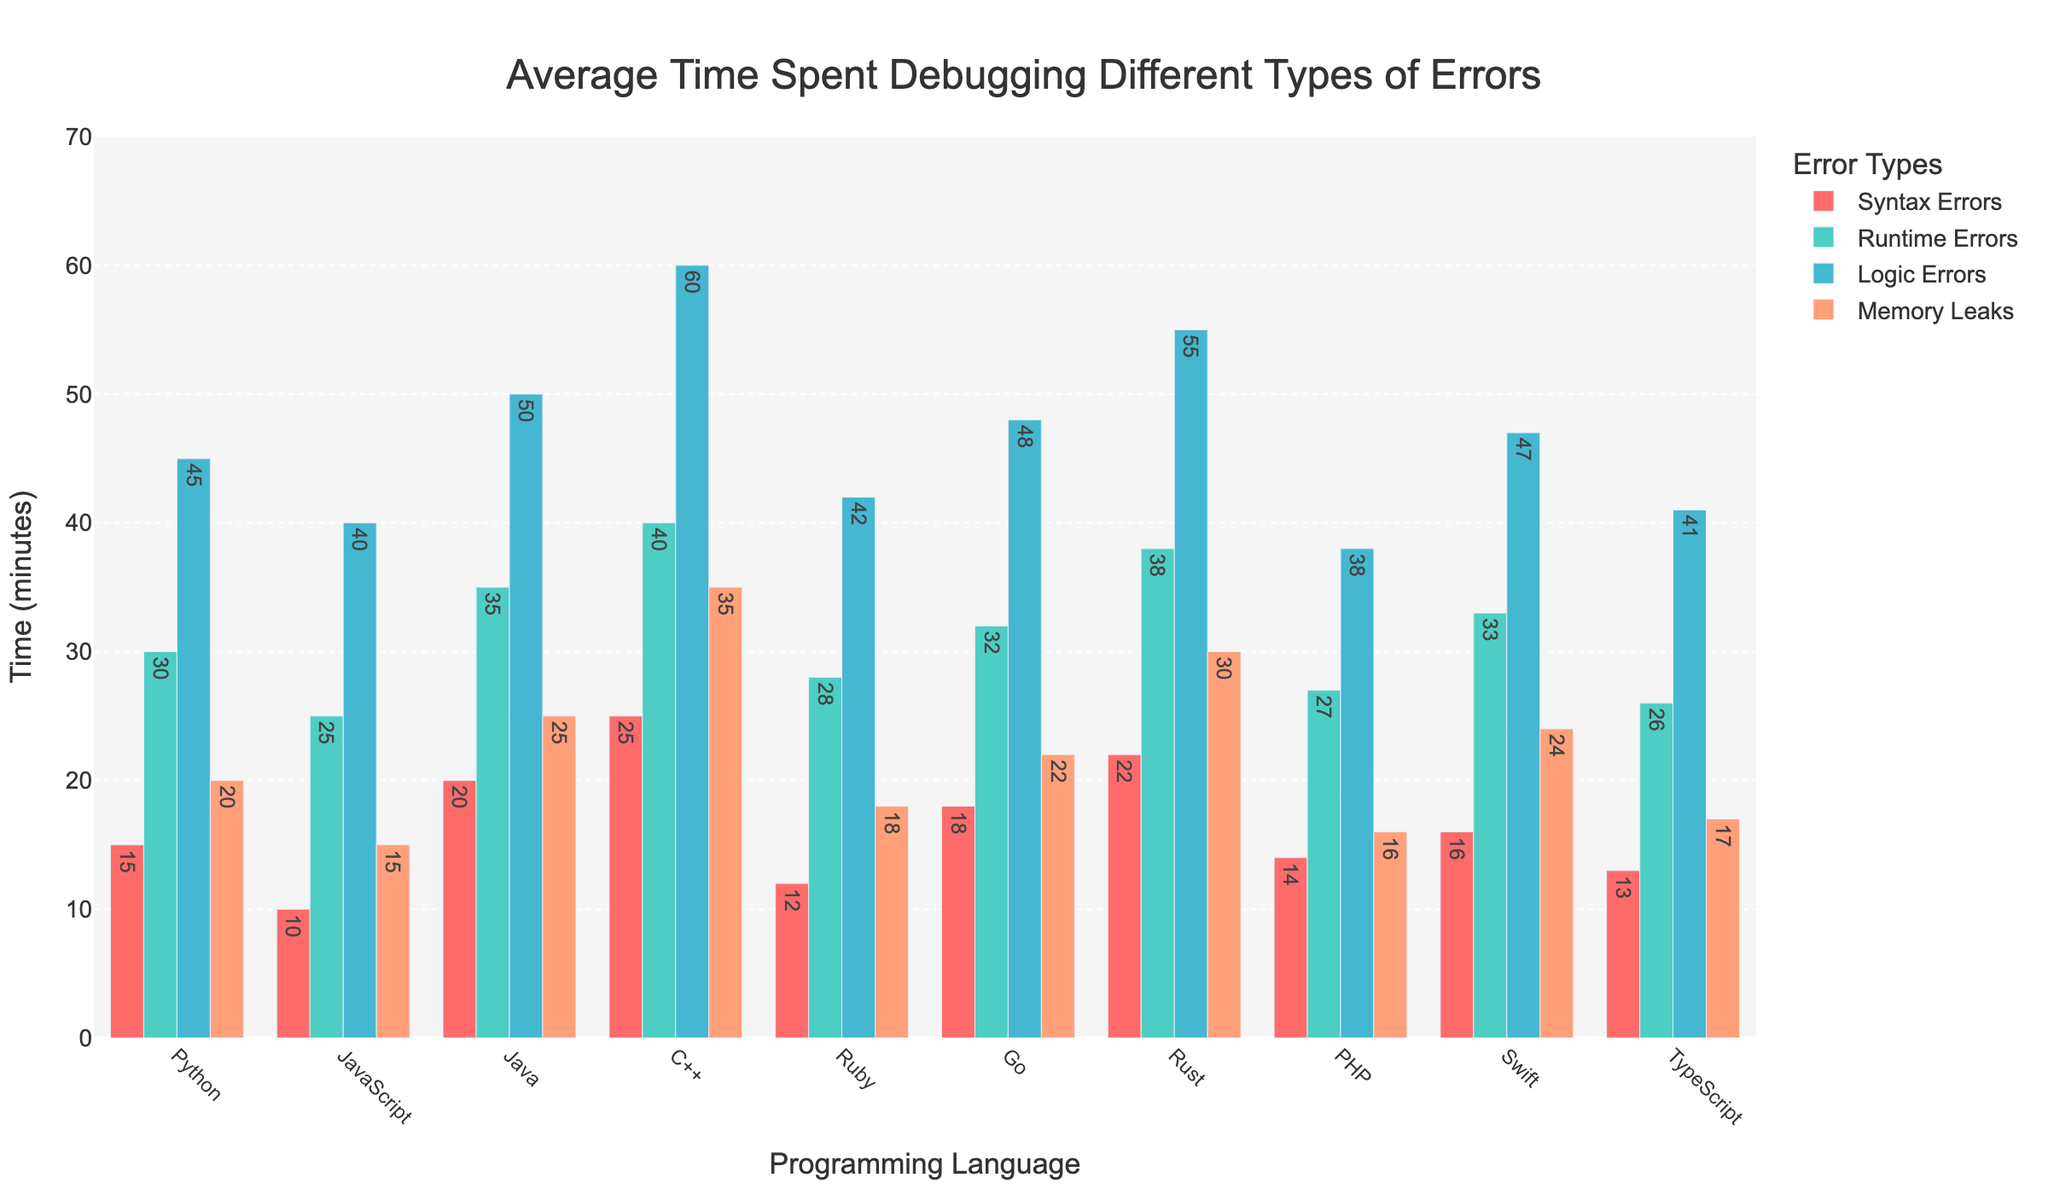Which language spends the most time debugging logic errors? Look at the bar heights for "Logic Errors" across all languages. C++ has the tallest bar for "Logic Errors", indicating it spends the most time.
Answer: C++ Which language spends the least time debugging memory leaks? Look at the bar heights for "Memory Leaks" across all languages. JavaScript has the shortest bar for "Memory Leaks", indicating it spends the least time.
Answer: JavaScript How much more time does Python spend on runtime errors compared to TypeScript? Compare the heights of the "Runtime Errors" bars for Python and TypeScript. Python’s bar is at 30 minutes, and TypeScript’s is at 26 minutes. The difference is 30 - 26 = 4 minutes.
Answer: 4 minutes What's the total time spent debugging all types of errors for Rust? Sum the heights of all bars for Rust. The times are 22 (Syntax Errors) + 38 (Runtime Errors) + 55 (Logic Errors) + 30 (Memory Leaks), which equals 145 minutes.
Answer: 145 minutes Which error type does Swift spend the most time debugging? Compare the heights of the bars for Swift. The tallest bar represents "Logic Errors" at 47 minutes, indicating Swift spends the most time on this error type.
Answer: Logic Errors What's the average time spent debugging runtime errors across all languages? Sum the heights of the "Runtime Errors" bars for all languages, and then divide by the number of languages. The total is 274, and there are 10 languages, so the average is 274 / 10 = 27.4 minutes.
Answer: 27.4 minutes Which type of error has the highest average debugging time across all languages? Calculate the average time for each error type by summing their respective values across languages and dividing by the number of languages. Logic Errors have the highest total of 466, giving an average of 46.6 minutes, which is the highest.
Answer: Logic Errors How does the time spent on syntax errors in C++ compare to Java? Compare the heights of the "Syntax Errors" bars for C++ and Java. C++ spends 25 minutes while Java spends 20 minutes, so C++ spends 5 minutes more.
Answer: C++ spends 5 minutes more than Java What's the difference in average debugging time of memory leaks between Python and Go? Look at the "Memory Leaks" bars for Python and Go. Python's bar is at 20 minutes, and Go's is at 22 minutes, making the difference 22 - 20 = 2 minutes.
Answer: 2 minutes Which language has the most even distribution of debugging times across all error types? Look for the language where all bars are of similar height. Python has the closest bar heights (15, 30, 45, 20), indicating a more even distribution of debugging times across all error types.
Answer: Python 